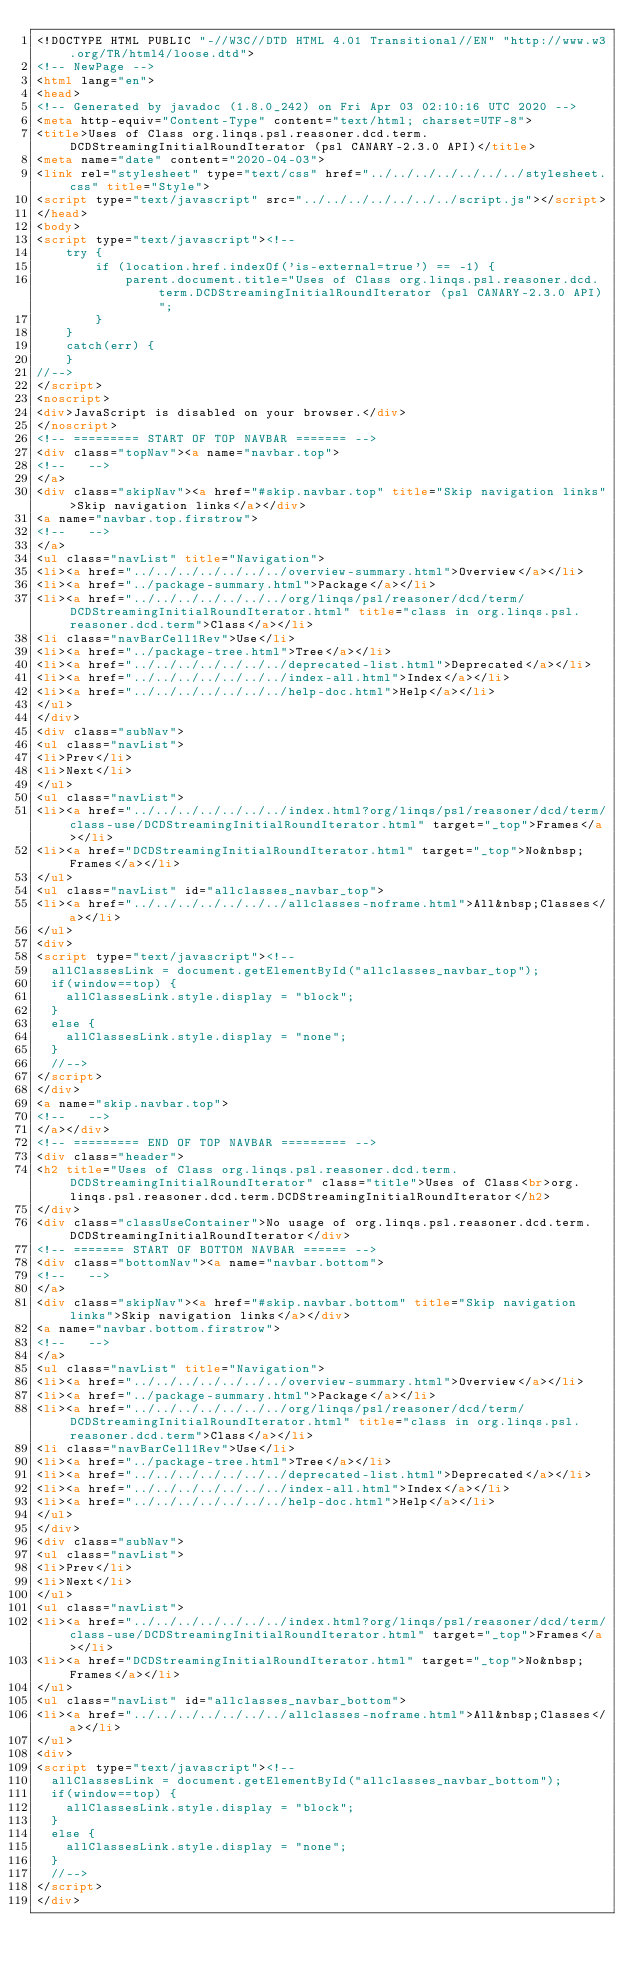<code> <loc_0><loc_0><loc_500><loc_500><_HTML_><!DOCTYPE HTML PUBLIC "-//W3C//DTD HTML 4.01 Transitional//EN" "http://www.w3.org/TR/html4/loose.dtd">
<!-- NewPage -->
<html lang="en">
<head>
<!-- Generated by javadoc (1.8.0_242) on Fri Apr 03 02:10:16 UTC 2020 -->
<meta http-equiv="Content-Type" content="text/html; charset=UTF-8">
<title>Uses of Class org.linqs.psl.reasoner.dcd.term.DCDStreamingInitialRoundIterator (psl CANARY-2.3.0 API)</title>
<meta name="date" content="2020-04-03">
<link rel="stylesheet" type="text/css" href="../../../../../../../stylesheet.css" title="Style">
<script type="text/javascript" src="../../../../../../../script.js"></script>
</head>
<body>
<script type="text/javascript"><!--
    try {
        if (location.href.indexOf('is-external=true') == -1) {
            parent.document.title="Uses of Class org.linqs.psl.reasoner.dcd.term.DCDStreamingInitialRoundIterator (psl CANARY-2.3.0 API)";
        }
    }
    catch(err) {
    }
//-->
</script>
<noscript>
<div>JavaScript is disabled on your browser.</div>
</noscript>
<!-- ========= START OF TOP NAVBAR ======= -->
<div class="topNav"><a name="navbar.top">
<!--   -->
</a>
<div class="skipNav"><a href="#skip.navbar.top" title="Skip navigation links">Skip navigation links</a></div>
<a name="navbar.top.firstrow">
<!--   -->
</a>
<ul class="navList" title="Navigation">
<li><a href="../../../../../../../overview-summary.html">Overview</a></li>
<li><a href="../package-summary.html">Package</a></li>
<li><a href="../../../../../../../org/linqs/psl/reasoner/dcd/term/DCDStreamingInitialRoundIterator.html" title="class in org.linqs.psl.reasoner.dcd.term">Class</a></li>
<li class="navBarCell1Rev">Use</li>
<li><a href="../package-tree.html">Tree</a></li>
<li><a href="../../../../../../../deprecated-list.html">Deprecated</a></li>
<li><a href="../../../../../../../index-all.html">Index</a></li>
<li><a href="../../../../../../../help-doc.html">Help</a></li>
</ul>
</div>
<div class="subNav">
<ul class="navList">
<li>Prev</li>
<li>Next</li>
</ul>
<ul class="navList">
<li><a href="../../../../../../../index.html?org/linqs/psl/reasoner/dcd/term/class-use/DCDStreamingInitialRoundIterator.html" target="_top">Frames</a></li>
<li><a href="DCDStreamingInitialRoundIterator.html" target="_top">No&nbsp;Frames</a></li>
</ul>
<ul class="navList" id="allclasses_navbar_top">
<li><a href="../../../../../../../allclasses-noframe.html">All&nbsp;Classes</a></li>
</ul>
<div>
<script type="text/javascript"><!--
  allClassesLink = document.getElementById("allclasses_navbar_top");
  if(window==top) {
    allClassesLink.style.display = "block";
  }
  else {
    allClassesLink.style.display = "none";
  }
  //-->
</script>
</div>
<a name="skip.navbar.top">
<!--   -->
</a></div>
<!-- ========= END OF TOP NAVBAR ========= -->
<div class="header">
<h2 title="Uses of Class org.linqs.psl.reasoner.dcd.term.DCDStreamingInitialRoundIterator" class="title">Uses of Class<br>org.linqs.psl.reasoner.dcd.term.DCDStreamingInitialRoundIterator</h2>
</div>
<div class="classUseContainer">No usage of org.linqs.psl.reasoner.dcd.term.DCDStreamingInitialRoundIterator</div>
<!-- ======= START OF BOTTOM NAVBAR ====== -->
<div class="bottomNav"><a name="navbar.bottom">
<!--   -->
</a>
<div class="skipNav"><a href="#skip.navbar.bottom" title="Skip navigation links">Skip navigation links</a></div>
<a name="navbar.bottom.firstrow">
<!--   -->
</a>
<ul class="navList" title="Navigation">
<li><a href="../../../../../../../overview-summary.html">Overview</a></li>
<li><a href="../package-summary.html">Package</a></li>
<li><a href="../../../../../../../org/linqs/psl/reasoner/dcd/term/DCDStreamingInitialRoundIterator.html" title="class in org.linqs.psl.reasoner.dcd.term">Class</a></li>
<li class="navBarCell1Rev">Use</li>
<li><a href="../package-tree.html">Tree</a></li>
<li><a href="../../../../../../../deprecated-list.html">Deprecated</a></li>
<li><a href="../../../../../../../index-all.html">Index</a></li>
<li><a href="../../../../../../../help-doc.html">Help</a></li>
</ul>
</div>
<div class="subNav">
<ul class="navList">
<li>Prev</li>
<li>Next</li>
</ul>
<ul class="navList">
<li><a href="../../../../../../../index.html?org/linqs/psl/reasoner/dcd/term/class-use/DCDStreamingInitialRoundIterator.html" target="_top">Frames</a></li>
<li><a href="DCDStreamingInitialRoundIterator.html" target="_top">No&nbsp;Frames</a></li>
</ul>
<ul class="navList" id="allclasses_navbar_bottom">
<li><a href="../../../../../../../allclasses-noframe.html">All&nbsp;Classes</a></li>
</ul>
<div>
<script type="text/javascript"><!--
  allClassesLink = document.getElementById("allclasses_navbar_bottom");
  if(window==top) {
    allClassesLink.style.display = "block";
  }
  else {
    allClassesLink.style.display = "none";
  }
  //-->
</script>
</div></code> 